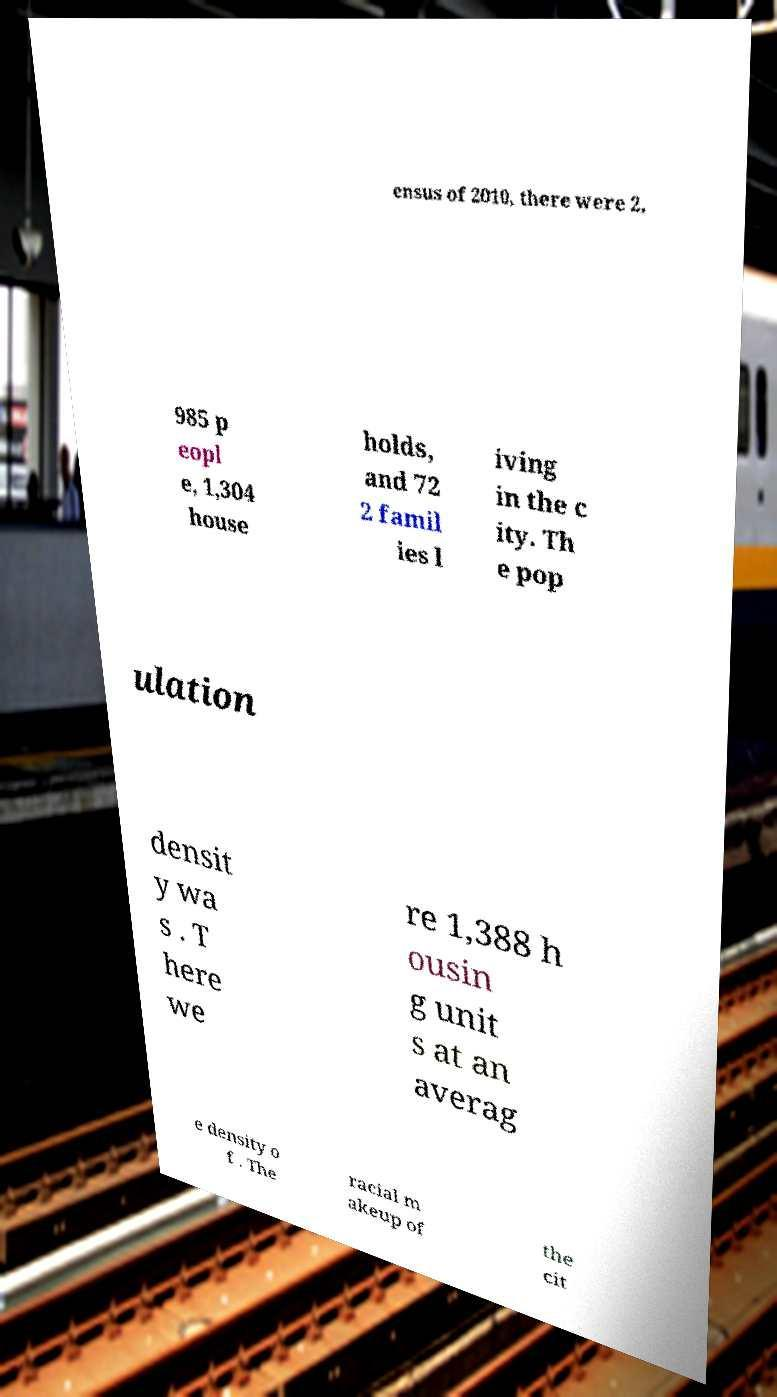For documentation purposes, I need the text within this image transcribed. Could you provide that? ensus of 2010, there were 2, 985 p eopl e, 1,304 house holds, and 72 2 famil ies l iving in the c ity. Th e pop ulation densit y wa s . T here we re 1,388 h ousin g unit s at an averag e density o f . The racial m akeup of the cit 